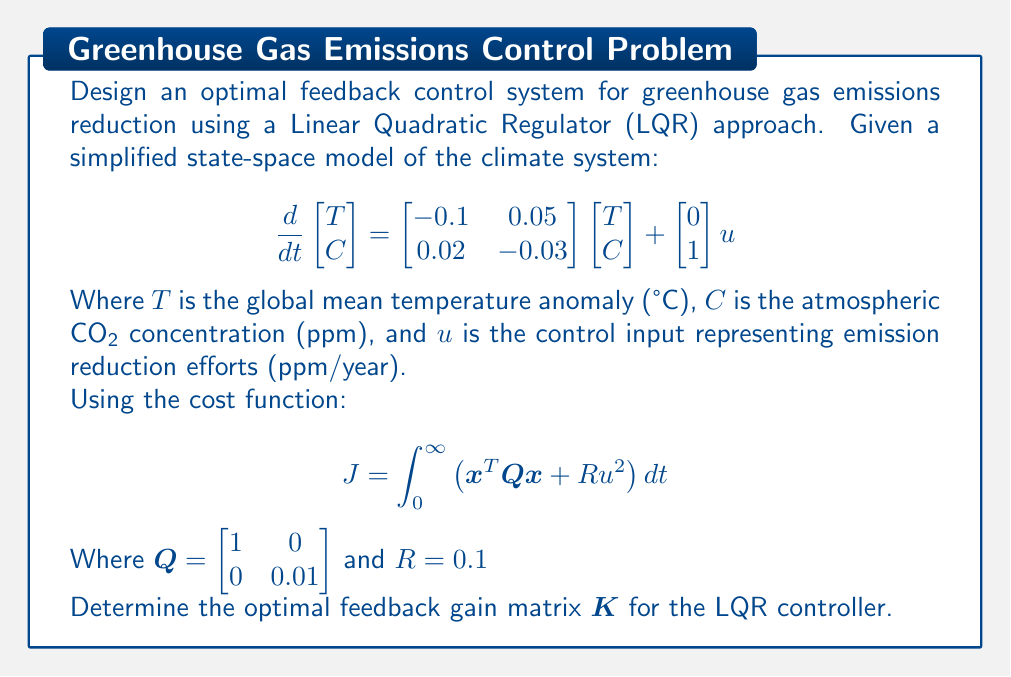Can you solve this math problem? To solve this problem, we need to follow these steps:

1. Identify the system matrices:
   $A = \begin{bmatrix} -0.1 & 0.05 \\ 0.02 & -0.03 \end{bmatrix}$
   $B = \begin{bmatrix} 0 \\ 1 \end{bmatrix}$

2. Confirm that the system is controllable by checking the rank of the controllability matrix:
   $\text{rank}([B \quad AB]) = 2$, which equals the number of states, so the system is controllable.

3. Solve the Algebraic Riccati Equation (ARE):
   $A^TP + PA - PBR^{-1}B^TP + Q = 0$

   This can be solved using numerical methods or software tools like MATLAB's 'lqr' function.

4. Calculate the optimal feedback gain matrix:
   $K = R^{-1}B^TP$

Using MATLAB's 'lqr' function, we can solve this problem with the following code:

```matlab
A = [-0.1 0.05; 0.02 -0.03];
B = [0; 1];
Q = [1 0; 0 0.01];
R = 0.1;

[K, P, E] = lqr(A, B, Q, R);
```

The resulting optimal feedback gain matrix K is:
$$K = \begin{bmatrix} 0.3162 & -3.1943 \end{bmatrix}$$

This gain matrix minimizes the cost function J and provides the optimal control law:

$$u = -Kx = -0.3162T + 3.1943C$$

The negative signs indicate that as temperature or CO2 concentration increases, more emission reduction efforts should be applied.
Answer: The optimal feedback gain matrix for the LQR controller is:

$$K = \begin{bmatrix} 0.3162 & -3.1943 \end{bmatrix}$$ 